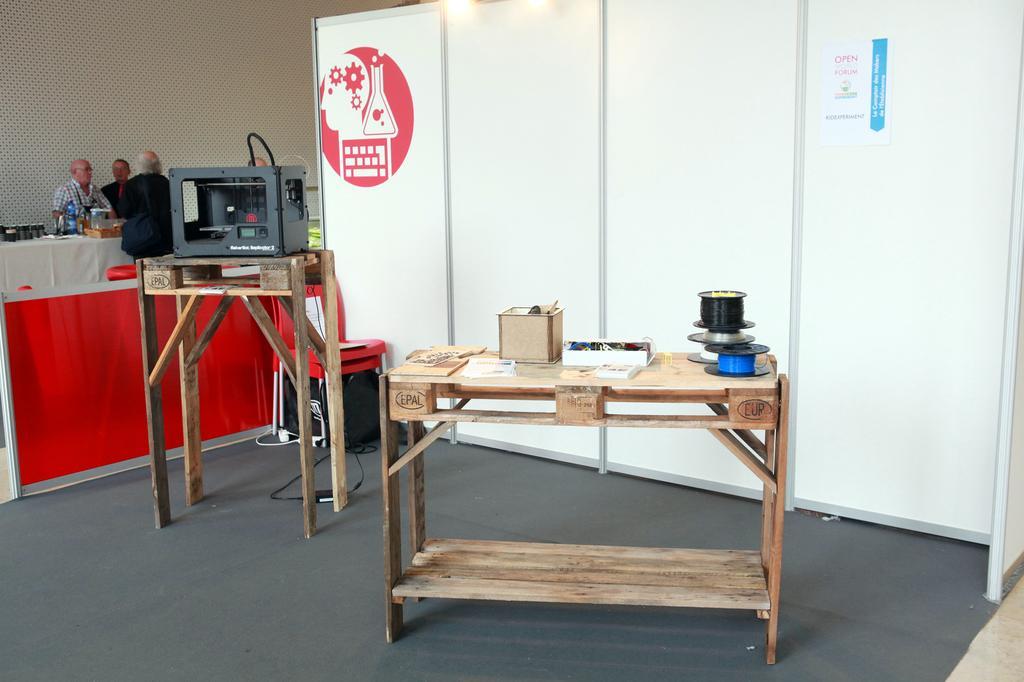Describe this image in one or two sentences. There is a wooden table. On that there are boxes and some other items. There is another wooden table. On that there is an electronic device. In the back there is a white wall. On that there is an image. In the background there are some people sitting. Near to them there is a table. On that some things are there. Also there is a wall in the background. 